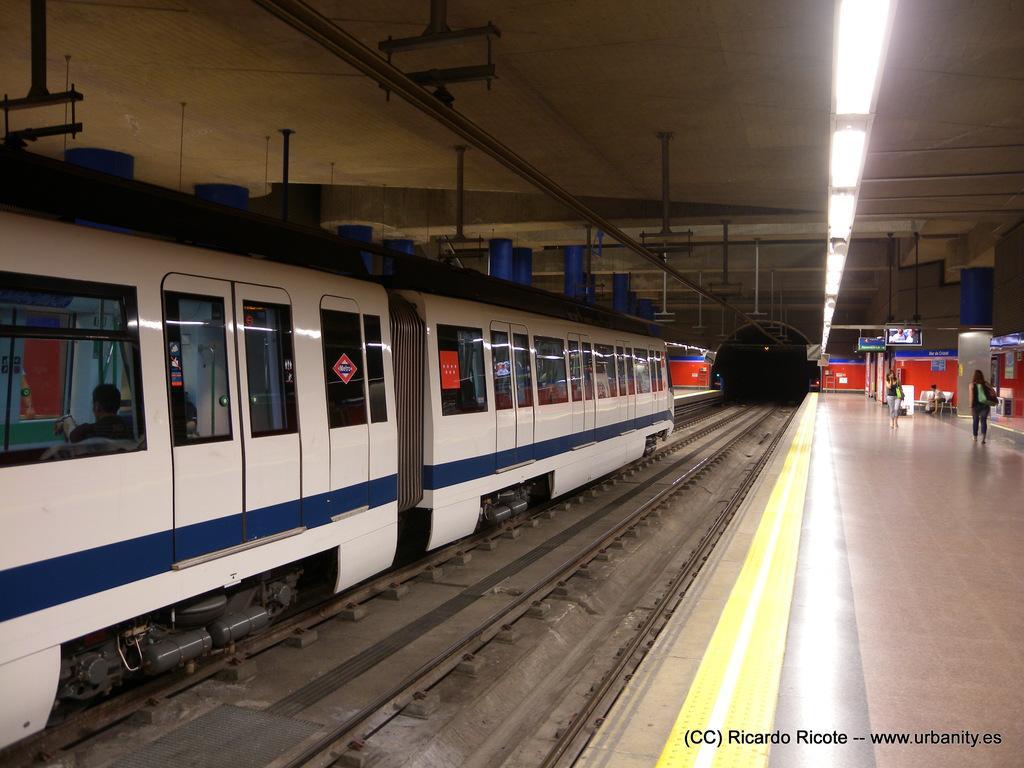Can you describe this image briefly? On the bottom right, there is a watermark. On the right side, there are persons walking on a platform. On the left side, there is a train on a railway track. Beside this railway track, there is another railway track. Above them, there is a roof. In the background, there are screens arranged, there is an orange color wall and there are other objects. 